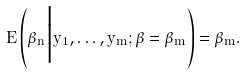Convert formula to latex. <formula><loc_0><loc_0><loc_500><loc_500>E \left ( \hat { \beta } _ { n } \Big | y _ { 1 } , \dots , y _ { m } ; \beta = \hat { \beta } _ { m } \right ) = \hat { \beta } _ { m } .</formula> 